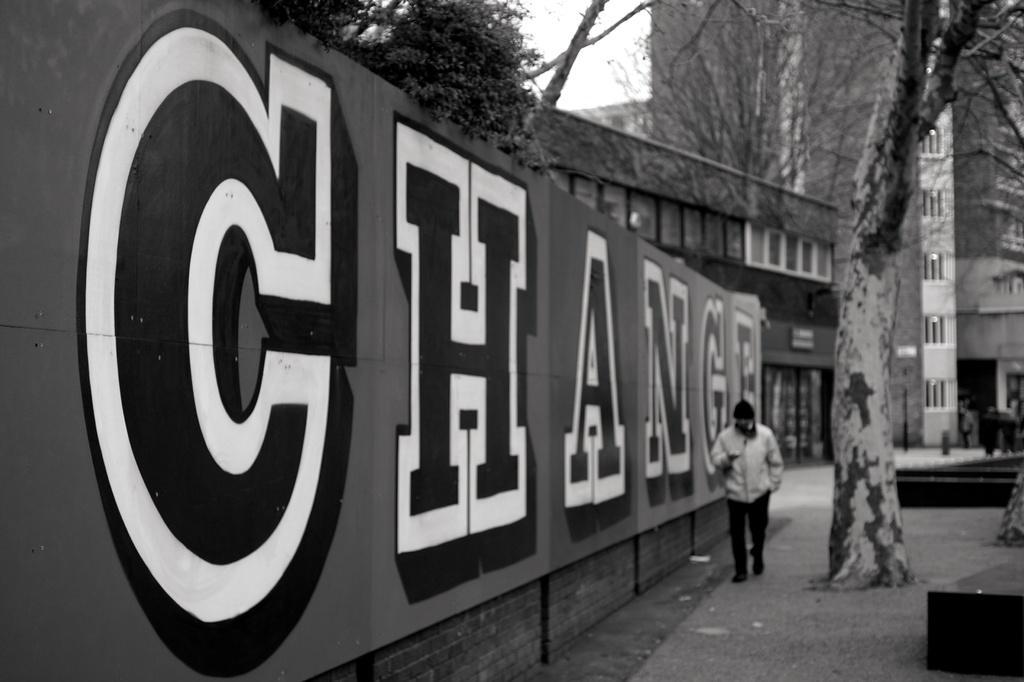Can you describe this image briefly? In the picture we can see a wooden wall on it, we can see a name CHANGE beside to it, we can see a man walking and beside it, we can see a tree and in the background, we can see some building with glass windows and behind it also we can see some buildings and sky. 